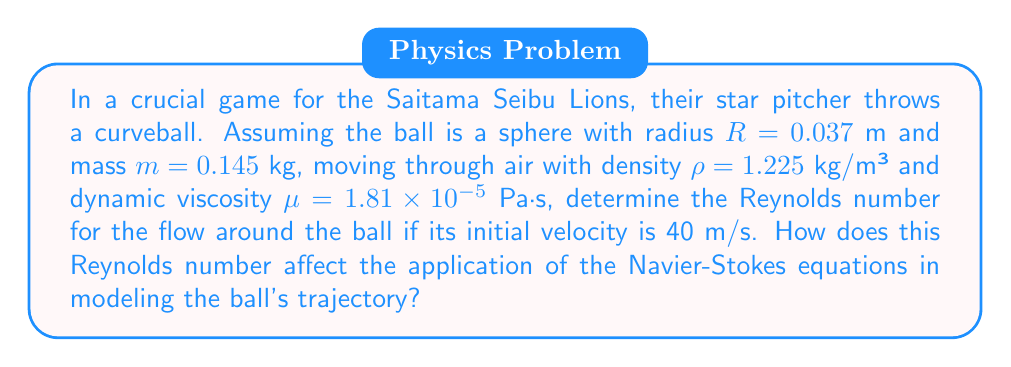Help me with this question. To solve this problem, we need to calculate the Reynolds number and then discuss its implications on the Navier-Stokes equations for modeling the curveball's trajectory.

1. Calculate the Reynolds number:
The Reynolds number is given by the formula:

$$ Re = \frac{\rho v D}{\mu} $$

Where:
$\rho$ is the density of the fluid (air)
$v$ is the velocity of the object
$D$ is the characteristic length (diameter of the ball)
$\mu$ is the dynamic viscosity of the fluid

Let's substitute the values:

$\rho = 1.225$ kg/m³
$v = 40$ m/s
$D = 2R = 2 \times 0.037 = 0.074$ m
$\mu = 1.81 \times 10^{-5}$ Pa·s

$$ Re = \frac{1.225 \times 40 \times 0.074}{1.81 \times 10^{-5}} = 200,441 $$

2. Implications for the Navier-Stokes equations:

The high Reynolds number (Re > 4000) indicates that the flow around the baseball is turbulent. This has several implications for applying the Navier-Stokes equations to model the ball's trajectory:

a) Complexity: The full Navier-Stokes equations must be used, as simplifications like the Stokes flow approximation are not valid for high Reynolds numbers.

b) Turbulence modeling: Additional turbulence models (e.g., k-ε or k-ω models) may be needed to account for the complex flow patterns.

c) Boundary layer: A thin boundary layer will form around the ball, requiring fine mesh resolution near the surface for accurate numerical simulations.

d) Magnus effect: The spin of the curveball will create asymmetric flow patterns, leading to the Magnus effect. This must be accounted for in the boundary conditions of the Navier-Stokes equations.

e) Computational resources: Solving the full Navier-Stokes equations for this high Reynolds number flow will require significant computational power and time.

f) Time-dependent solution: The flow is likely to be unsteady, requiring time-dependent solutions of the Navier-Stokes equations.

g) Non-linear effects: At high Reynolds numbers, non-linear terms in the Navier-Stokes equations become more significant, making the solution more challenging.
Answer: The Reynolds number for the curveball is approximately 200,441. This high Reynolds number indicates turbulent flow, necessitating the use of the full Navier-Stokes equations with appropriate turbulence models, careful treatment of the boundary layer, and consideration of the Magnus effect to accurately model the ball's trajectory. 